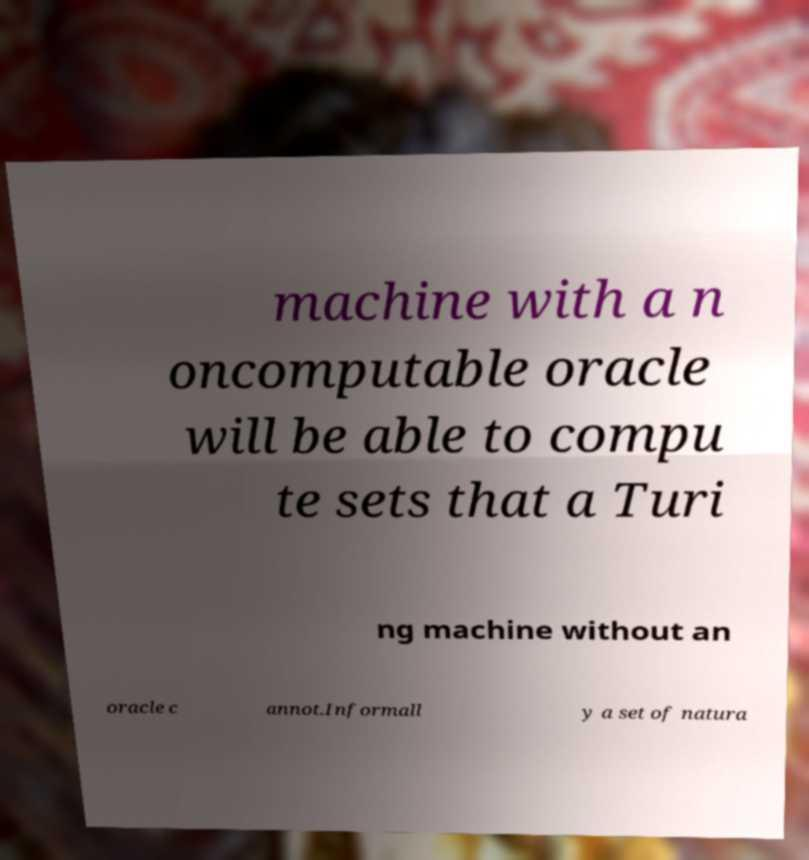I need the written content from this picture converted into text. Can you do that? machine with a n oncomputable oracle will be able to compu te sets that a Turi ng machine without an oracle c annot.Informall y a set of natura 